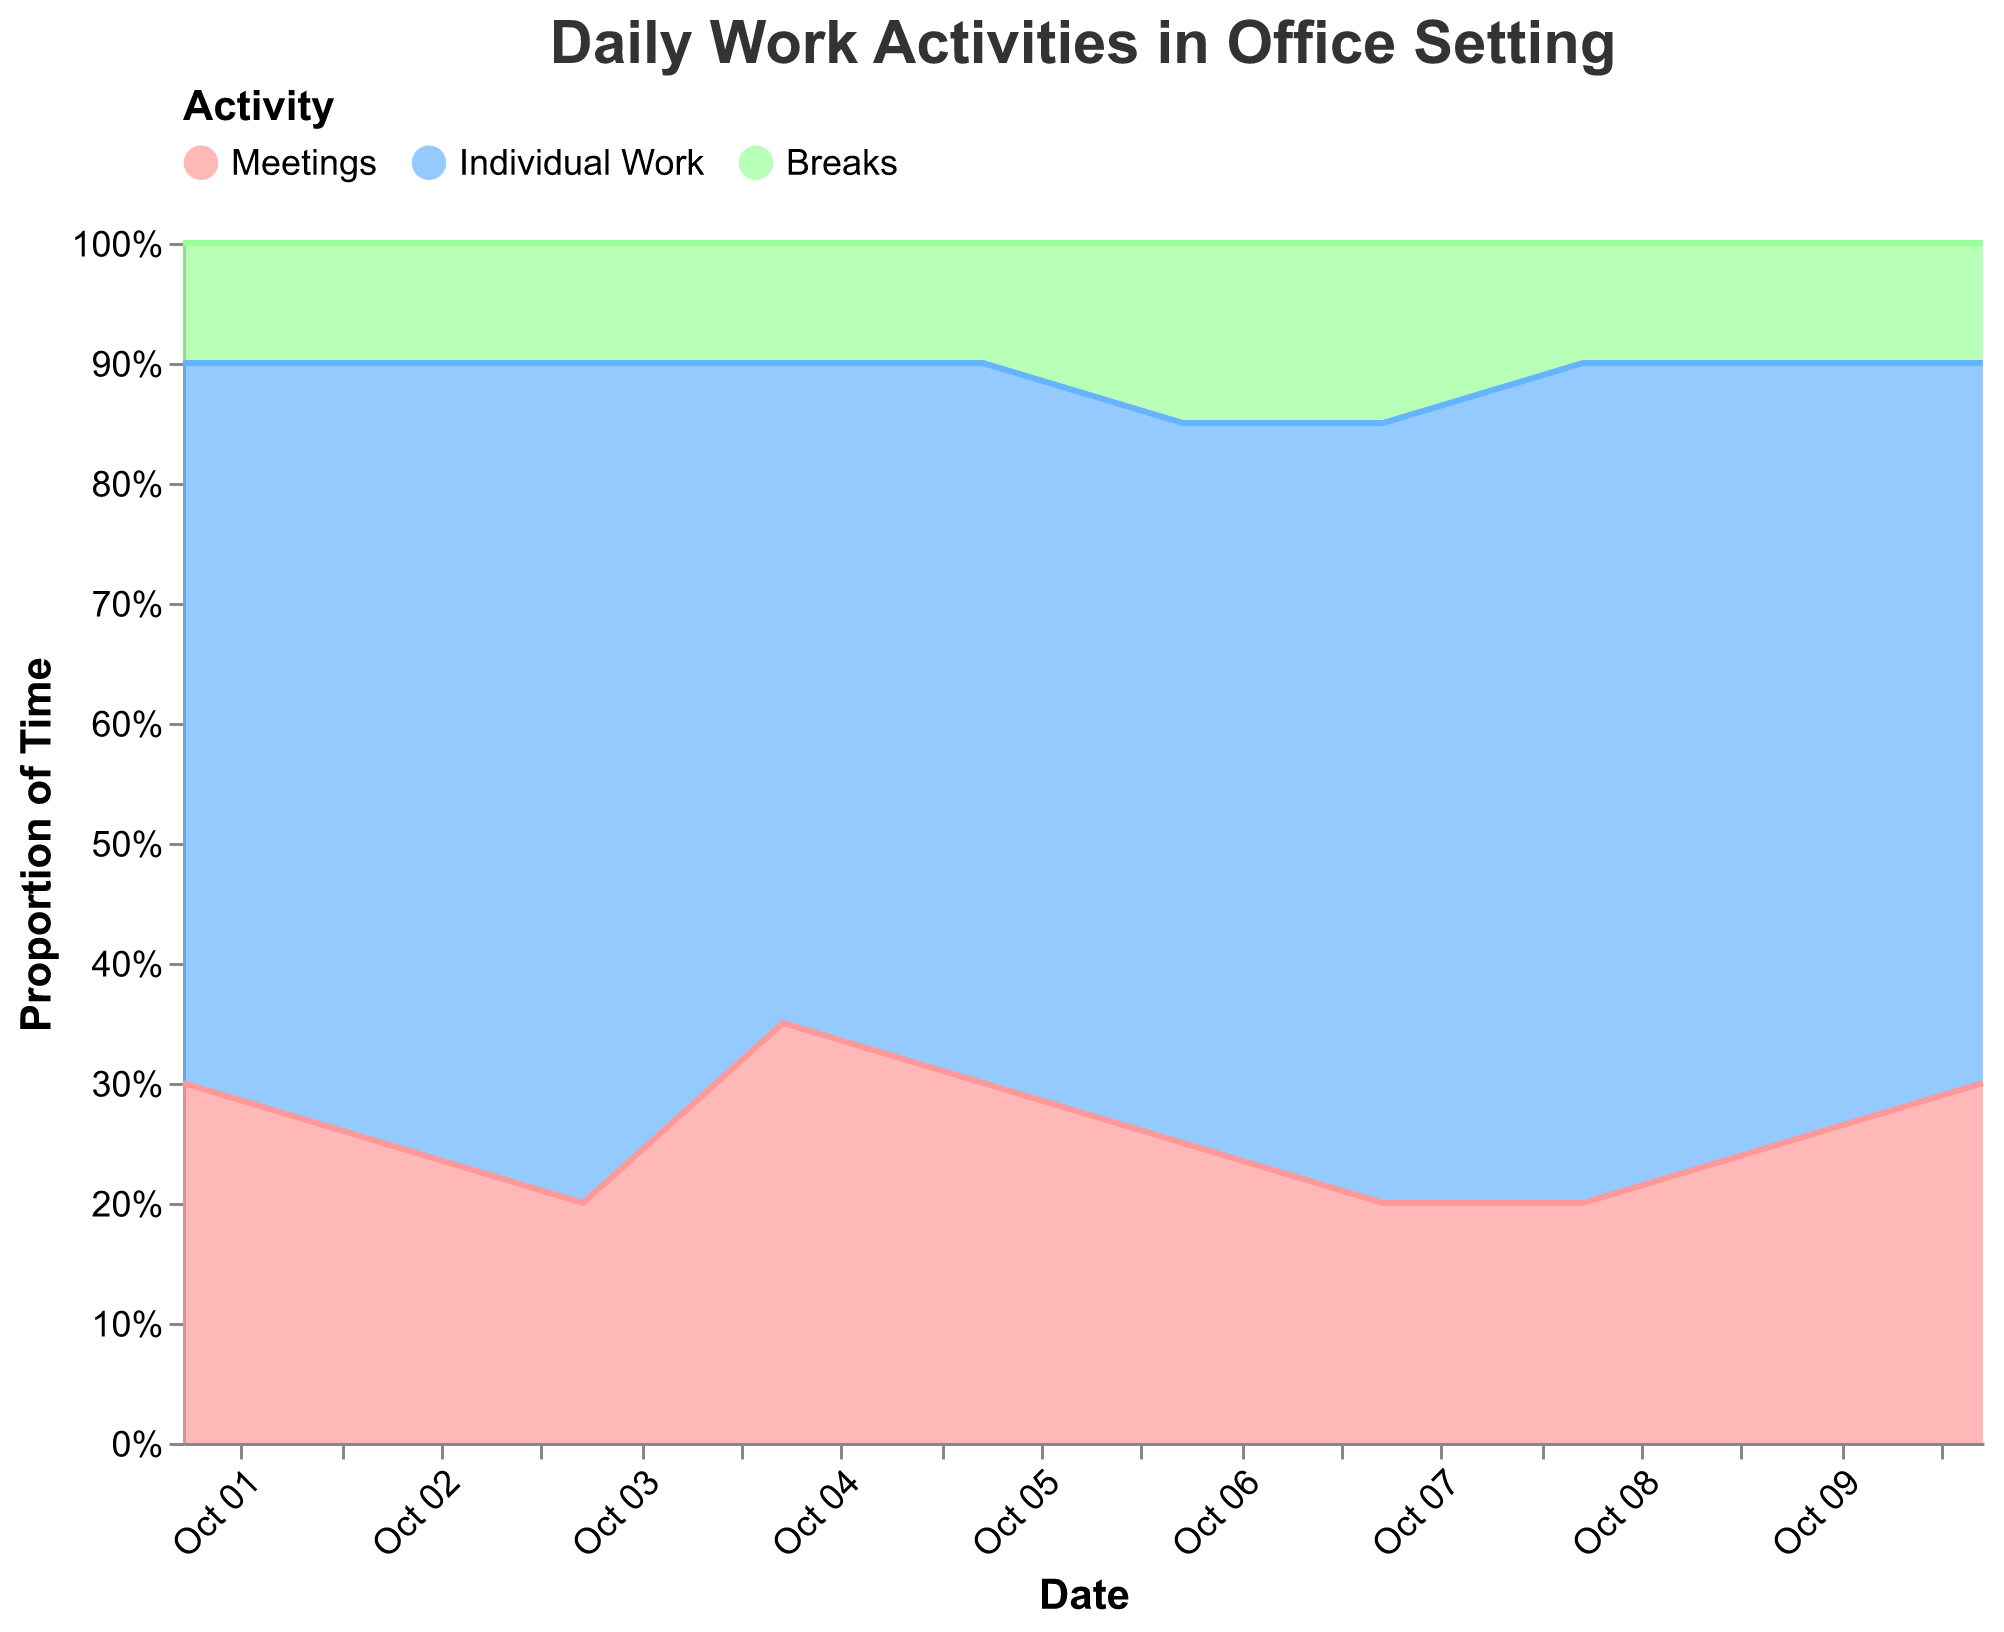what is the title of the chart? The title is displayed at the top of the chart in large text.
Answer: Daily Work Activities in Office Setting How many activities are represented in the chart? There are three distinct colors in the legend which represent different activities.
Answer: Three on which date did meetings take up the highest proportion of time? Meetings are represented by a light red color. The highest area for this color occurs on October 4th.
Answer: October 4th What trend can be observed for breaks from October 1st to October 10th? Breaks are in green. Initially, the proportion is consistent for the first five days, slight increase from October 6th to 7th, then it returns to original level.
Answer: Generally stable with a slight increase on October 6th and 7th Which activity showed the most consistency in its proportion over time? By comparing the color segments' height, we see the green (Breaks) portion is most stable.
Answer: Breaks What can you infer about the relationship between meetings and individual work? Observing the chart shows an inverse relationship where when meetings increase, individual work decreases and vice versa.
Answer: Inversely related On which date did breaks take up the highest proportion of time? Breaks can be traced by the green area, which peaks on October 6th and 7th.
Answer: October 6th and 7th What is the average proportion of time spent on individual work over these 10 days? Add the proportions for all 10 days (60+65+70+55+60+60+65+70+65+60) and divide by 10.
Answer: 63% Which activity saw the greatest fluctuation in its proportion over the 10 days? Comparing heights of segments, Meetings (red) varied the most between 20% to 35%.
Answer: Meetings Is there a day where the proportion of time spent on each activity is the same? Check each date to see if Meetings, Individual Work, and Breaks each take up equal parts.
Answer: No 